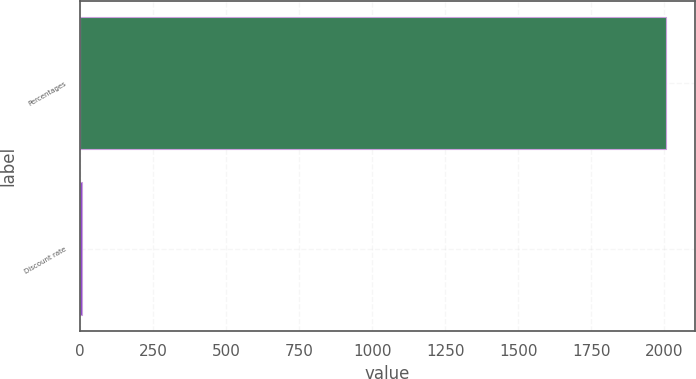<chart> <loc_0><loc_0><loc_500><loc_500><bar_chart><fcel>Percentages<fcel>Discount rate<nl><fcel>2005<fcel>5.75<nl></chart> 